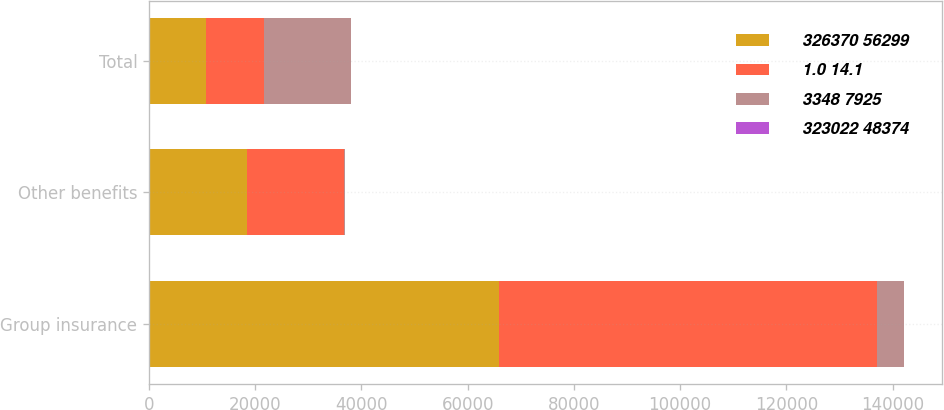Convert chart. <chart><loc_0><loc_0><loc_500><loc_500><stacked_bar_chart><ecel><fcel>Group insurance<fcel>Other benefits<fcel>Total<nl><fcel>326370 56299<fcel>65872<fcel>18422<fcel>10808<nl><fcel>1.0 14.1<fcel>71103<fcel>18303<fcel>10808<nl><fcel>3348 7925<fcel>5231<fcel>119<fcel>16385<nl><fcel>323022 48374<fcel>7.4<fcel>0.7<fcel>3.5<nl></chart> 